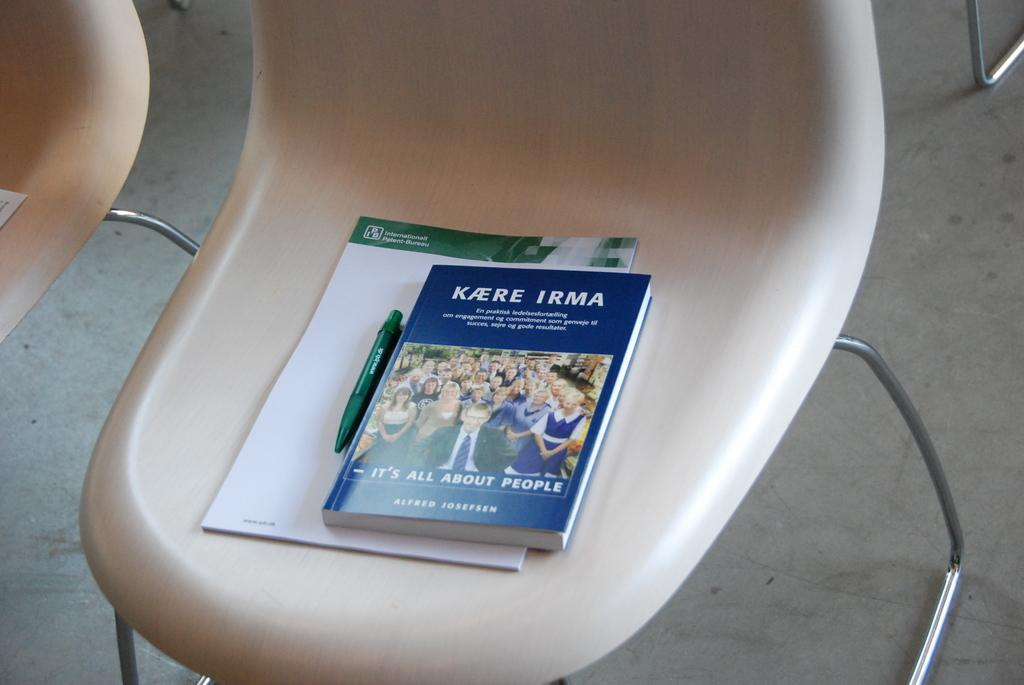What type of book is in the image? There is a blue color book in the image. What writing instrument is in the image? There is a pen in the image. What is the pen used for in the image? The pen is likely used for writing on the paper in the image. Where are the items located in the image? The items are on a chair. What is the chair's structure like in the image? The chair has a stand. What surface is visible beneath the chair in the image? The floor is visible in the image. What type of cloth is draped over the chair in the image? There is no cloth draped over the chair in the image; only the book, pen, paper, and chair are present. What direction is the church facing in the image? There is no church present in the image. 